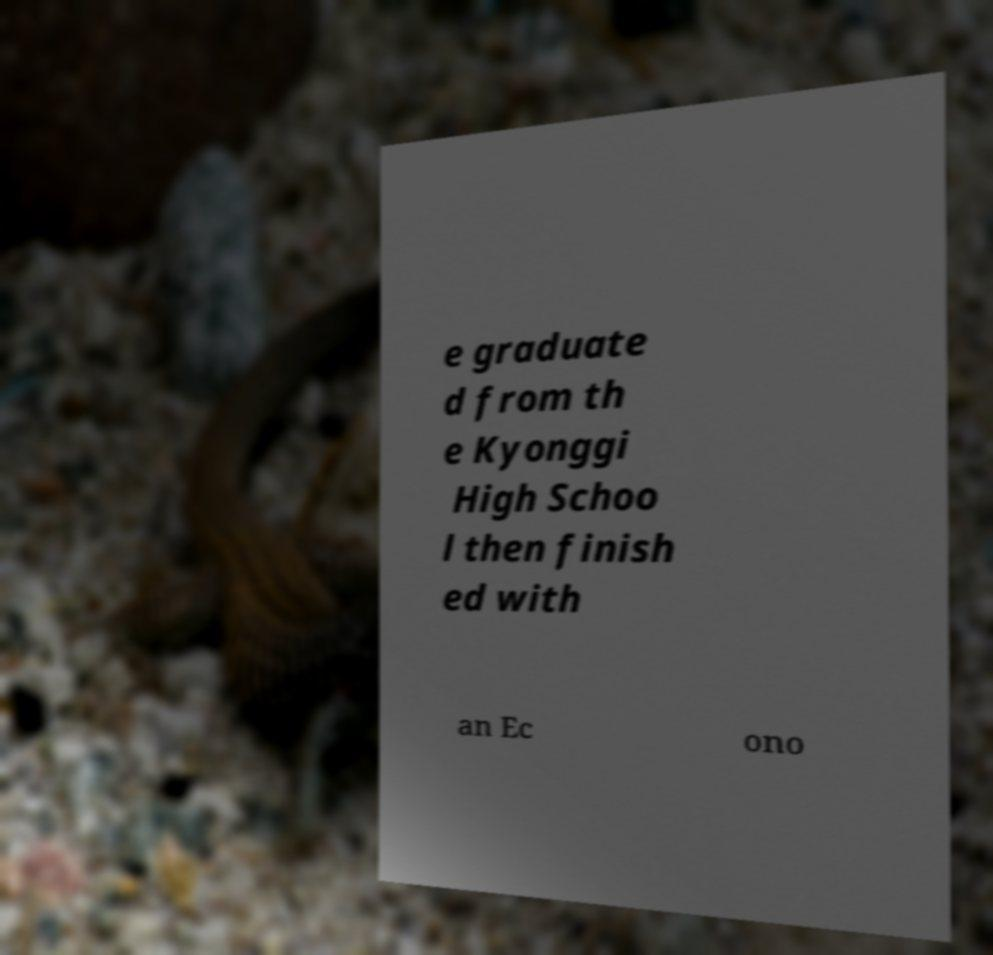Can you accurately transcribe the text from the provided image for me? e graduate d from th e Kyonggi High Schoo l then finish ed with an Ec ono 